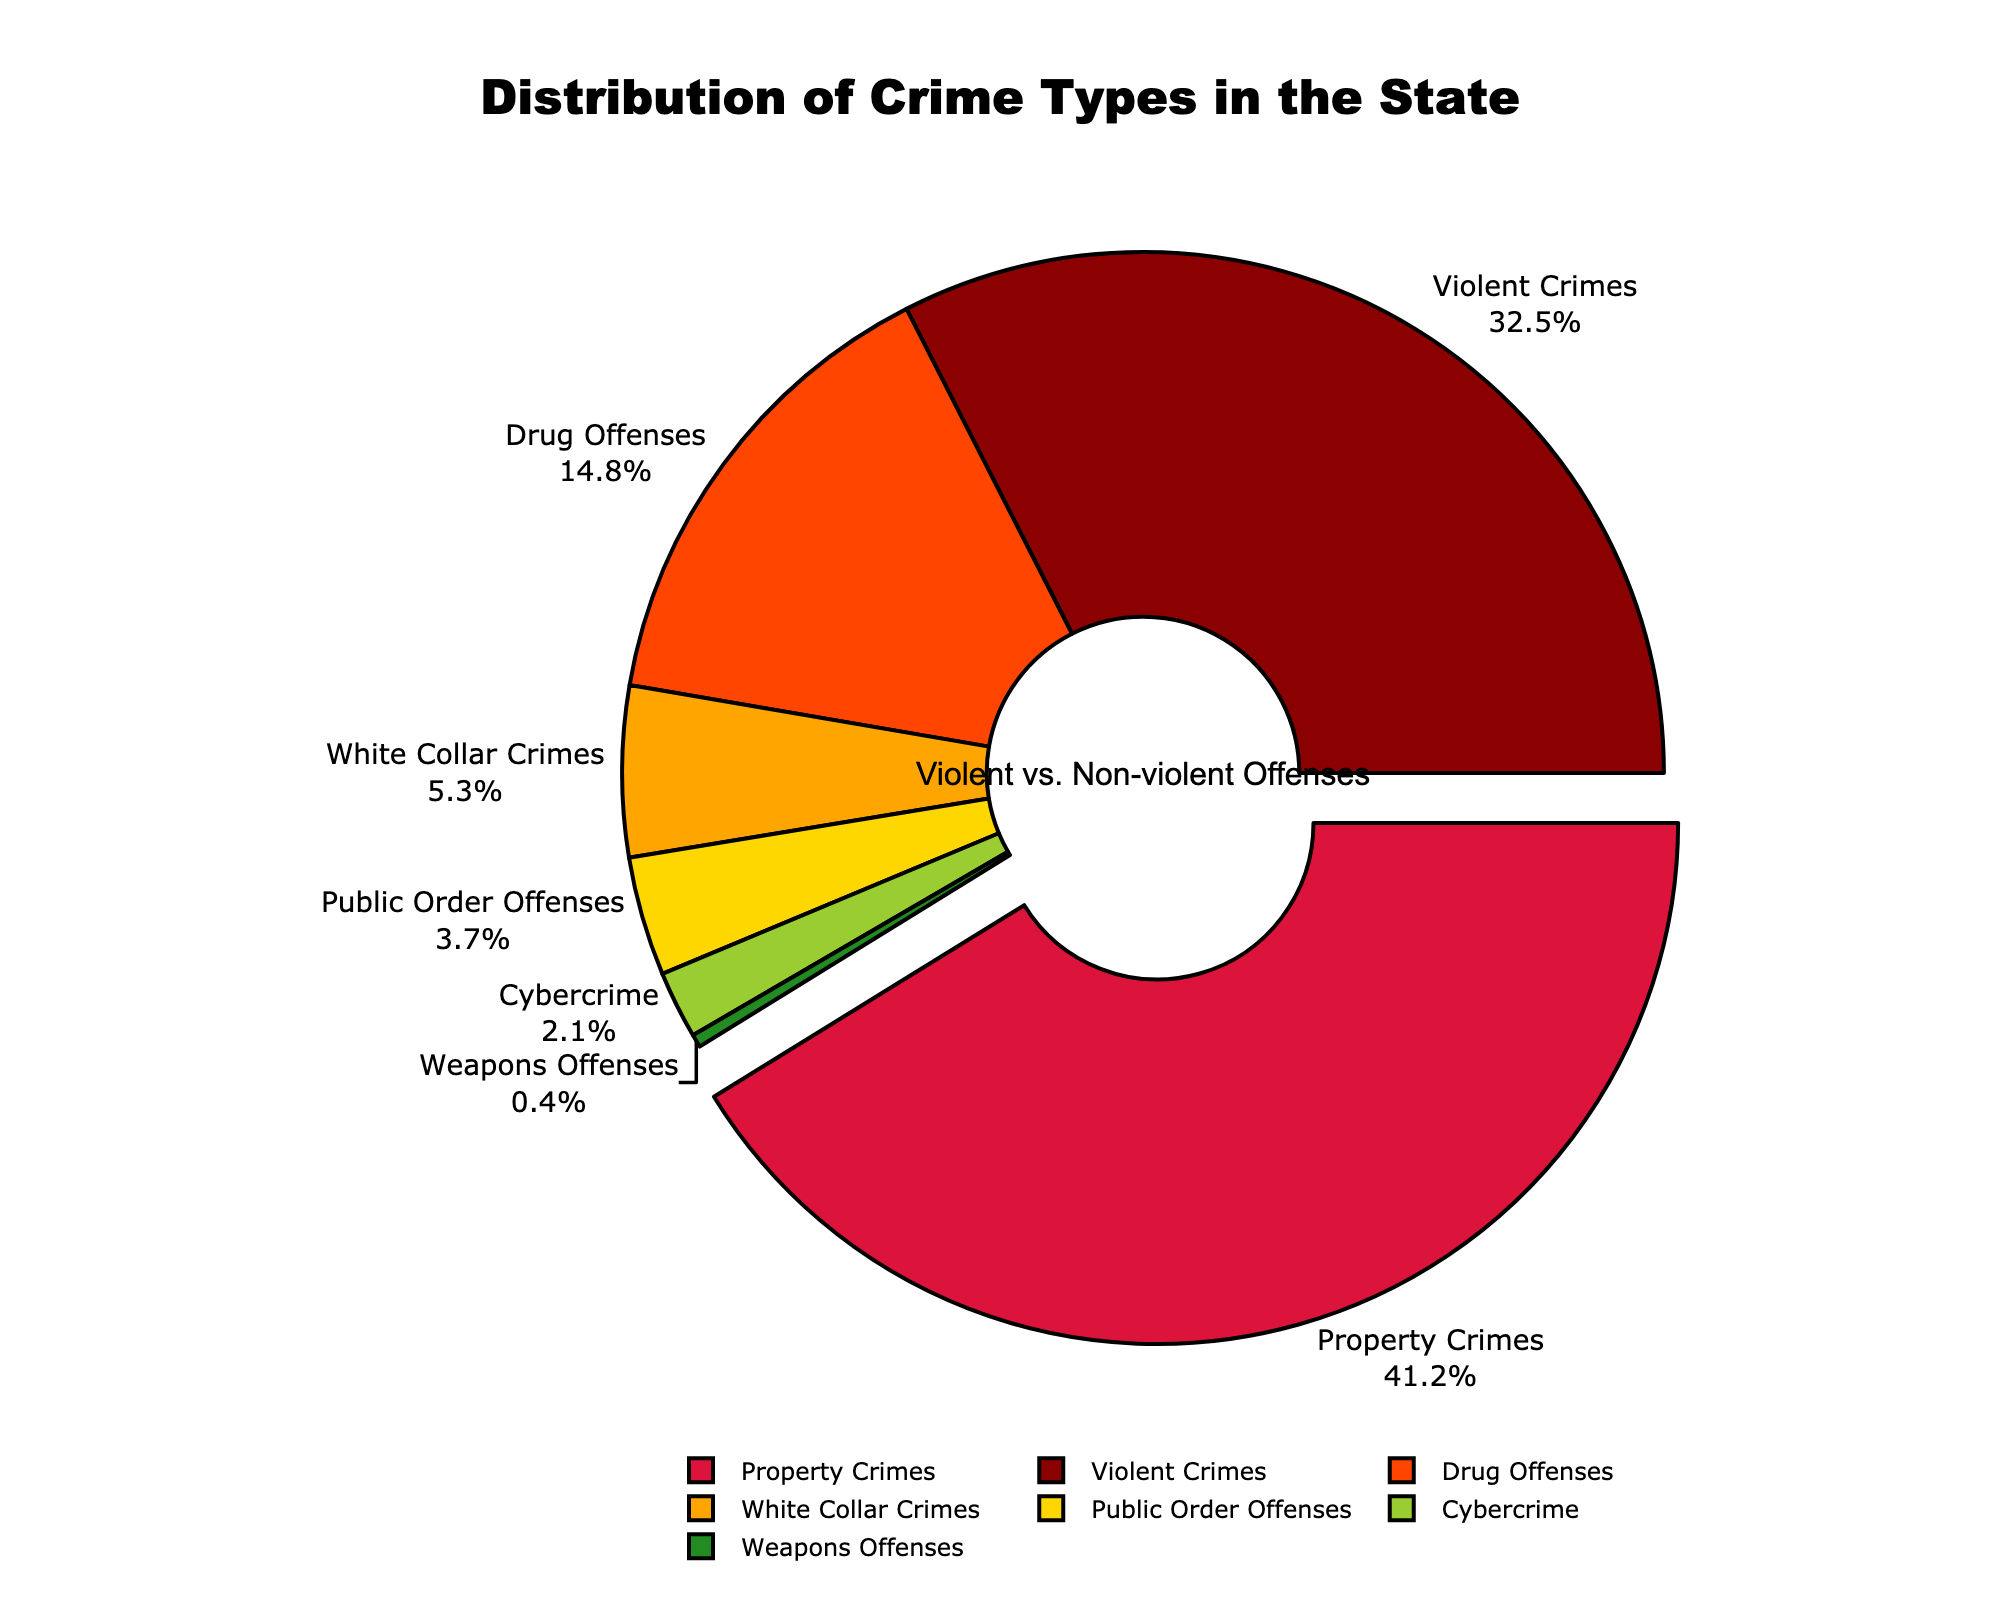What percentage of crimes fall under violent offenses? Locate Violent Crimes on the chart and read its percentage.
Answer: 32.5% By how much do property crimes exceed drug offenses in percentage terms? Find the percentages for Property Crimes and Drug Offenses, subtract the value for Drug Offenses from Property Crimes: 41.2% - 14.8% = 26.4%
Answer: 26.4% What is the combined percentage of White Collar Crimes and Public Order Offenses? Find the percentages for White Collar Crimes and Public Order Offenses, then sum them: 5.3% + 3.7% = 9.0%
Answer: 9.0% Which type of crime has the highest percentage, and what is it? Identify the segment that is pulled out, which indicates the highest value: Property Crimes at 41.2%
Answer: Property Crimes, 41.2% Are non-violent crimes more prevalent than violent crimes? Calculate the total percentage of non-violent crimes: Property Crimes (41.2%) + Drug Offenses (14.8%) + White Collar Crimes (5.3%) + Public Order Offenses (3.7%) + Cybercrime (2.1%) + Weapons Offenses (0.4%) = 67.5%. Compare it to Violent Crimes (32.5%). 67.5% > 32.5%
Answer: Yes Which crime type has the smallest representation, and what is its percentage? Find the segment with the smallest percentage; this is the Weapons Offenses at 0.4%
Answer: Weapons Offenses, 0.4% What visual cues indicate the most common crime type on the chart? The segment representing the most common crime type (Property Crimes) is pulled out from the pie and has a distinct color (orange).
Answer: Pulled out segment and color How do Public Order Offenses compare to Cybercrime in percentage terms? Locate the percentages for both Public Order Offenses and Cybercrime, then compare them: 3.7% for Public Order Offenses is greater than 2.1% for Cybercrime.
Answer: Public Order Offenses > Cybercrime What fraction of crimes are either Drug Offenses or White Collar Crimes? Sum the percentages of Drug Offenses and White Collar Crimes: 14.8% + 5.3% = 20.1%. Convert this to a fraction: 20.1/100 = 20.1% or 1/4.975
Answer: 20.1% or approximately 1/5 If Violent Crimes and Property Crimes are grouped together, what percentage do they represent? Sum the percentages of Violent Crimes and Property Crimes: 32.5% + 41.2% = 73.7%
Answer: 73.7% 